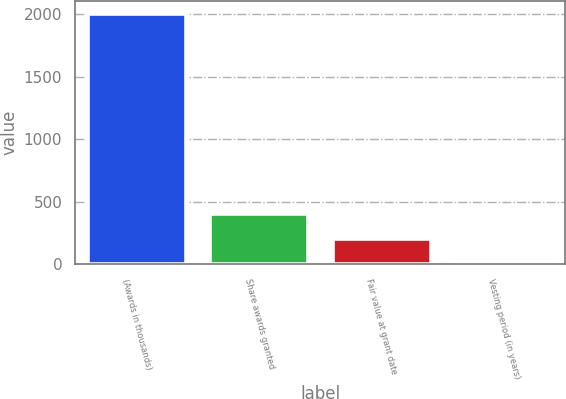Convert chart. <chart><loc_0><loc_0><loc_500><loc_500><bar_chart><fcel>(Awards in thousands)<fcel>Share awards granted<fcel>Fair value at grant date<fcel>Vesting period (in years)<nl><fcel>2005<fcel>403.4<fcel>203.2<fcel>3<nl></chart> 